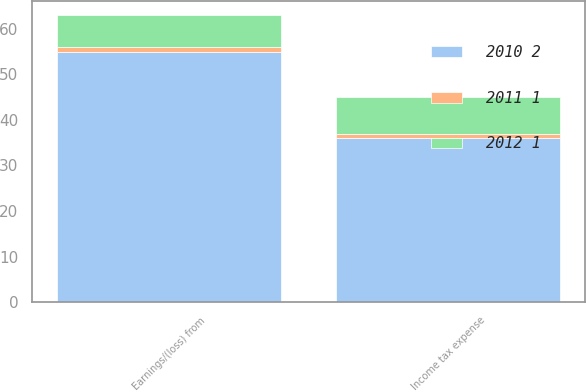Convert chart to OTSL. <chart><loc_0><loc_0><loc_500><loc_500><stacked_bar_chart><ecel><fcel>Income tax expense<fcel>Earnings/(loss) from<nl><fcel>2011 1<fcel>1<fcel>1<nl><fcel>2012 1<fcel>8<fcel>7<nl><fcel>2010 2<fcel>36<fcel>55<nl></chart> 